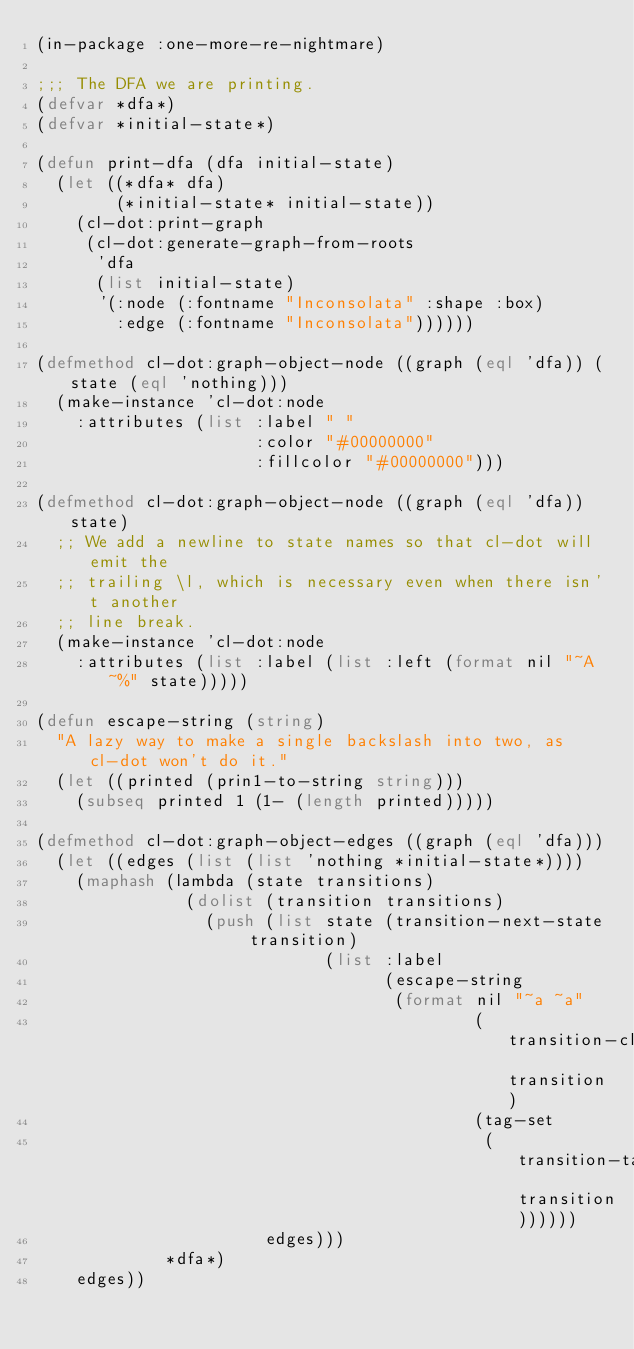Convert code to text. <code><loc_0><loc_0><loc_500><loc_500><_Lisp_>(in-package :one-more-re-nightmare)

;;; The DFA we are printing.
(defvar *dfa*)
(defvar *initial-state*)

(defun print-dfa (dfa initial-state)
  (let ((*dfa* dfa)
        (*initial-state* initial-state))
    (cl-dot:print-graph
     (cl-dot:generate-graph-from-roots
      'dfa
      (list initial-state)
      '(:node (:fontname "Inconsolata" :shape :box)
        :edge (:fontname "Inconsolata"))))))

(defmethod cl-dot:graph-object-node ((graph (eql 'dfa)) (state (eql 'nothing)))
  (make-instance 'cl-dot:node
    :attributes (list :label " "
                      :color "#00000000"
                      :fillcolor "#00000000")))

(defmethod cl-dot:graph-object-node ((graph (eql 'dfa)) state)
  ;; We add a newline to state names so that cl-dot will emit the
  ;; trailing \l, which is necessary even when there isn't another
  ;; line break.
  (make-instance 'cl-dot:node
    :attributes (list :label (list :left (format nil "~A~%" state)))))

(defun escape-string (string)
  "A lazy way to make a single backslash into two, as cl-dot won't do it."
  (let ((printed (prin1-to-string string)))
    (subseq printed 1 (1- (length printed)))))

(defmethod cl-dot:graph-object-edges ((graph (eql 'dfa)))
  (let ((edges (list (list 'nothing *initial-state*))))
    (maphash (lambda (state transitions)
               (dolist (transition transitions)
                 (push (list state (transition-next-state transition)
                             (list :label
                                   (escape-string
                                    (format nil "~a ~a"
                                            (transition-class transition)
                                            (tag-set
                                             (transition-tags-to-set transition))))))
                       edges)))
             *dfa*)
    edges))
</code> 